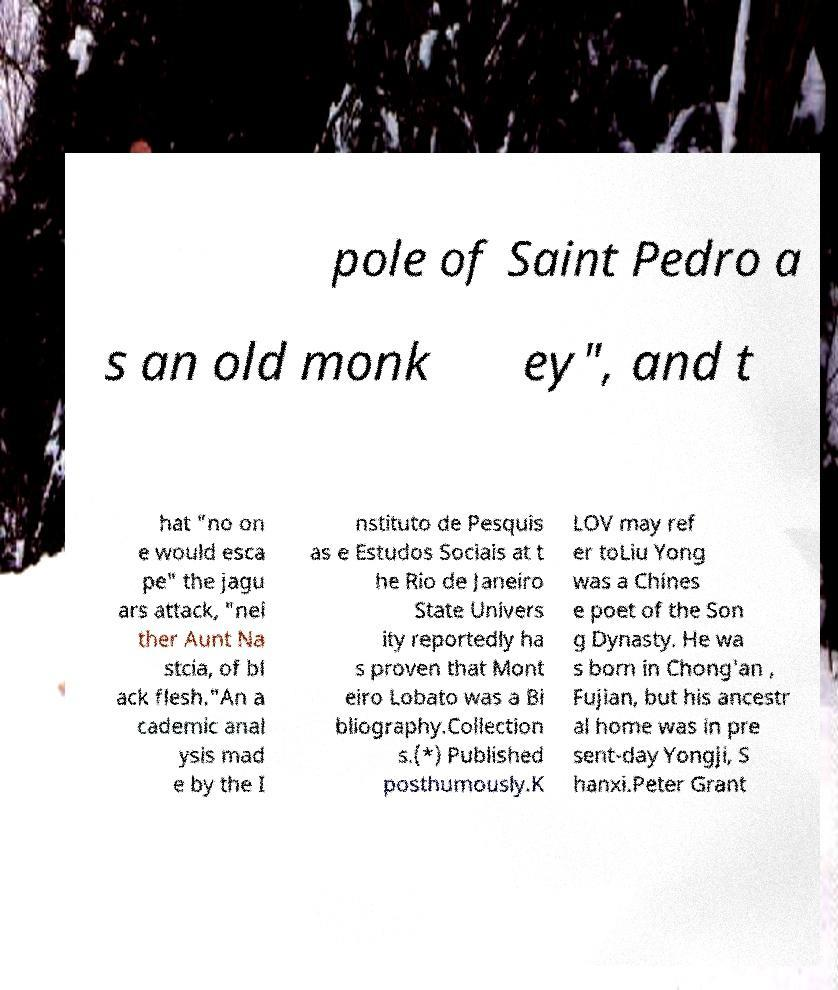Please identify and transcribe the text found in this image. pole of Saint Pedro a s an old monk ey", and t hat "no on e would esca pe" the jagu ars attack, "nei ther Aunt Na stcia, of bl ack flesh."An a cademic anal ysis mad e by the I nstituto de Pesquis as e Estudos Sociais at t he Rio de Janeiro State Univers ity reportedly ha s proven that Mont eiro Lobato was a Bi bliography.Collection s.(*) Published posthumously.K LOV may ref er toLiu Yong was a Chines e poet of the Son g Dynasty. He wa s born in Chong'an , Fujian, but his ancestr al home was in pre sent-day Yongji, S hanxi.Peter Grant 